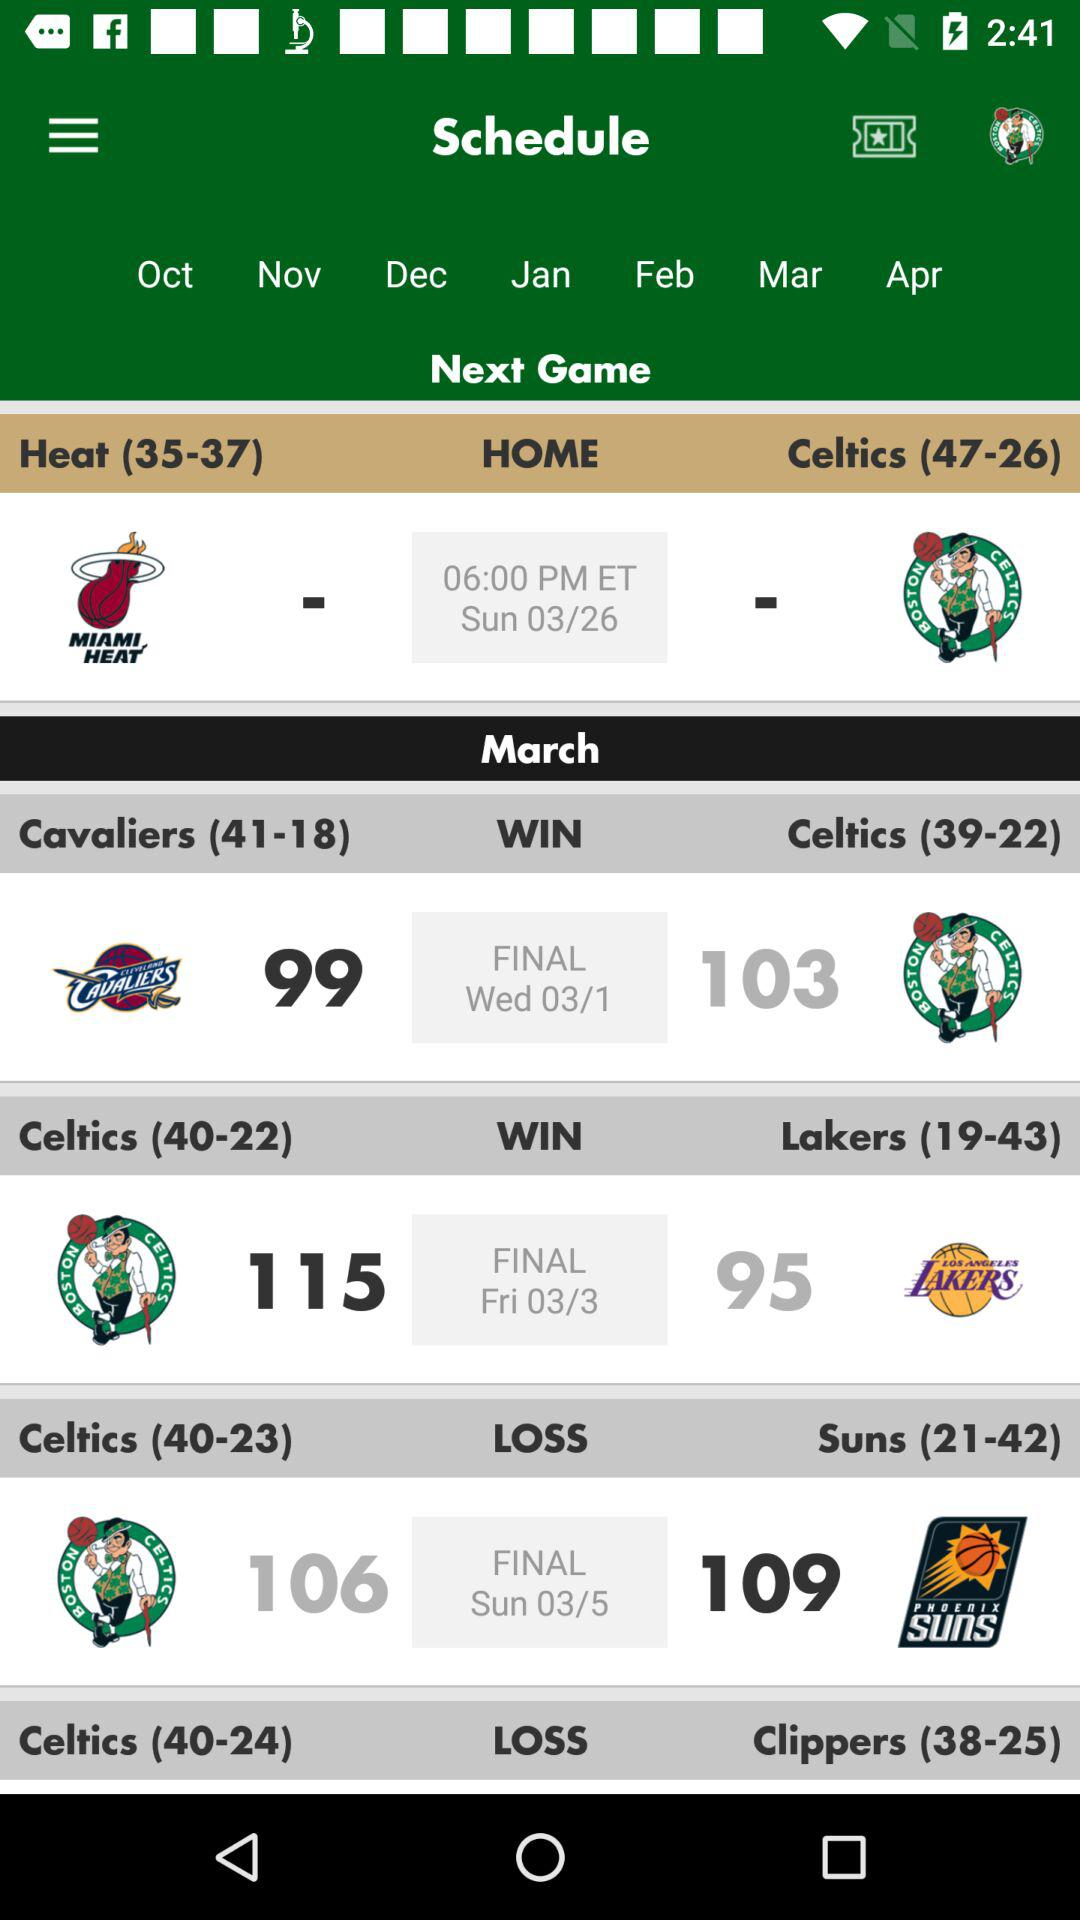Which team won the match?
When the provided information is insufficient, respond with <no answer>. <no answer> 